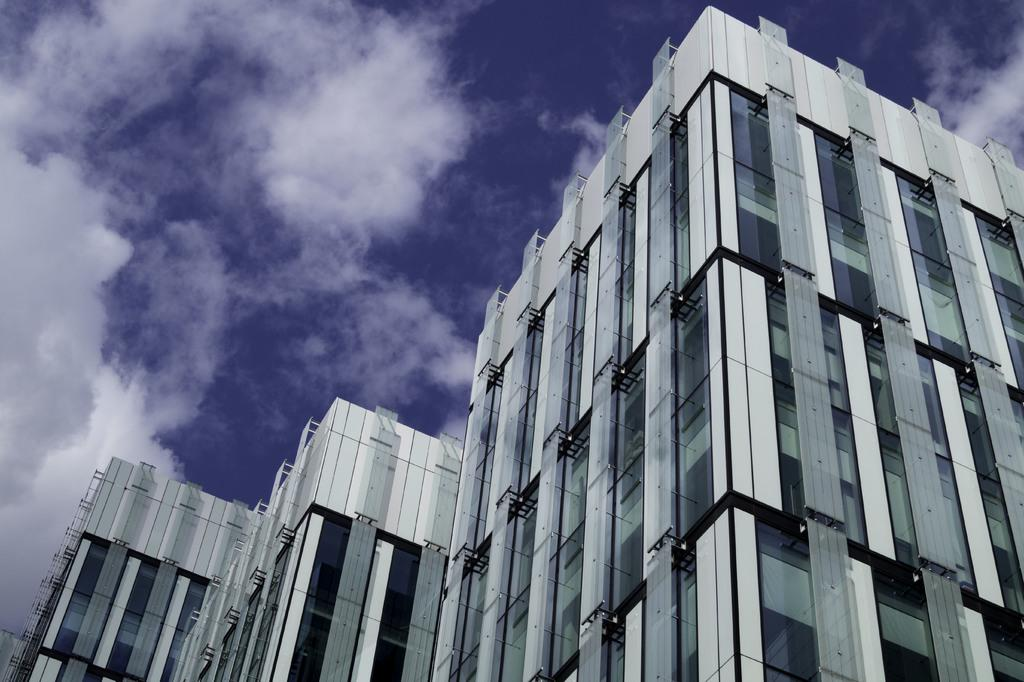What type of structures are present in the image? There are buildings in the image. What is the color of the buildings? The buildings are white in color. What feature can be observed on the buildings? The buildings have glass windows. What can be seen in the sky in the image? There are clouds visible in the image. What is the color of the sky in the image? The sky is blue in color. How does the channel affect the parcel during the rainstorm in the image? There is no channel, parcel, or rainstorm present in the image; it features white buildings with glass windows and a blue sky with clouds. 